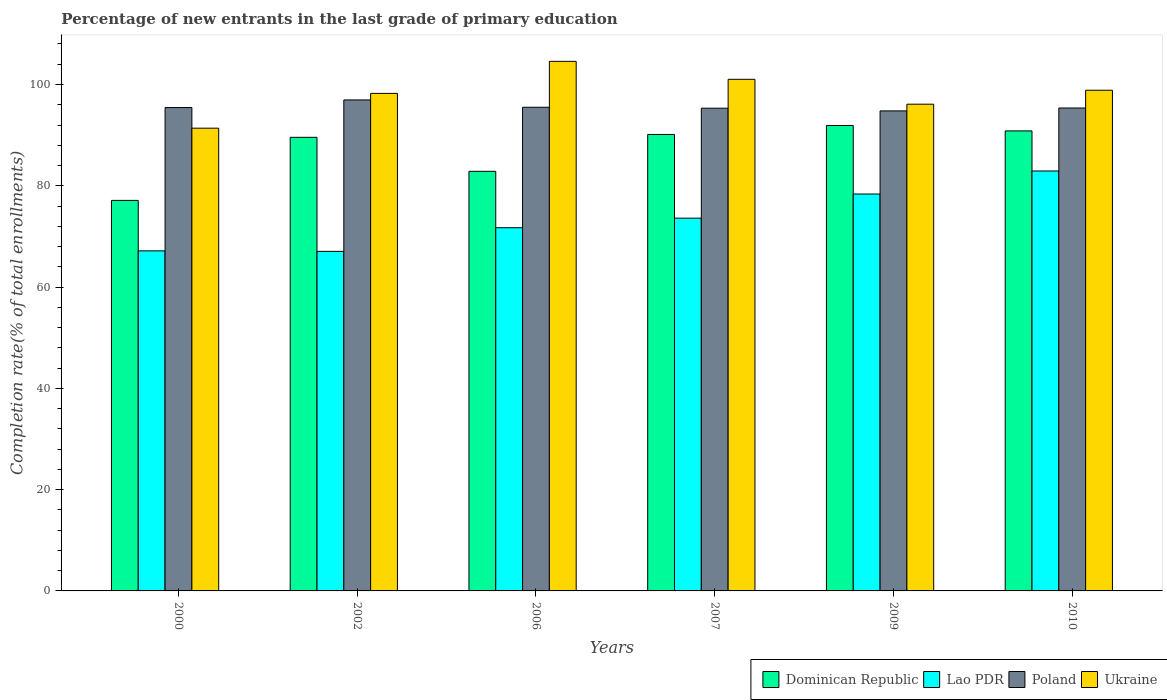How many different coloured bars are there?
Offer a very short reply. 4. What is the percentage of new entrants in Poland in 2006?
Your response must be concise. 95.51. Across all years, what is the maximum percentage of new entrants in Ukraine?
Provide a succinct answer. 104.57. Across all years, what is the minimum percentage of new entrants in Lao PDR?
Provide a succinct answer. 67.05. In which year was the percentage of new entrants in Ukraine maximum?
Your response must be concise. 2006. In which year was the percentage of new entrants in Poland minimum?
Provide a short and direct response. 2009. What is the total percentage of new entrants in Poland in the graph?
Provide a short and direct response. 573.39. What is the difference between the percentage of new entrants in Dominican Republic in 2000 and that in 2002?
Make the answer very short. -12.46. What is the difference between the percentage of new entrants in Lao PDR in 2000 and the percentage of new entrants in Dominican Republic in 2009?
Provide a succinct answer. -24.77. What is the average percentage of new entrants in Lao PDR per year?
Offer a terse response. 73.47. In the year 2010, what is the difference between the percentage of new entrants in Poland and percentage of new entrants in Lao PDR?
Your response must be concise. 12.44. What is the ratio of the percentage of new entrants in Poland in 2000 to that in 2010?
Offer a very short reply. 1. Is the percentage of new entrants in Ukraine in 2000 less than that in 2007?
Ensure brevity in your answer.  Yes. What is the difference between the highest and the second highest percentage of new entrants in Poland?
Your answer should be compact. 1.45. What is the difference between the highest and the lowest percentage of new entrants in Lao PDR?
Offer a terse response. 15.87. Is it the case that in every year, the sum of the percentage of new entrants in Ukraine and percentage of new entrants in Lao PDR is greater than the sum of percentage of new entrants in Poland and percentage of new entrants in Dominican Republic?
Give a very brief answer. Yes. What does the 4th bar from the left in 2000 represents?
Offer a very short reply. Ukraine. What does the 1st bar from the right in 2010 represents?
Offer a terse response. Ukraine. Are all the bars in the graph horizontal?
Keep it short and to the point. No. How many years are there in the graph?
Offer a very short reply. 6. What is the difference between two consecutive major ticks on the Y-axis?
Offer a terse response. 20. Are the values on the major ticks of Y-axis written in scientific E-notation?
Provide a succinct answer. No. Does the graph contain grids?
Make the answer very short. No. How are the legend labels stacked?
Keep it short and to the point. Horizontal. What is the title of the graph?
Ensure brevity in your answer.  Percentage of new entrants in the last grade of primary education. What is the label or title of the Y-axis?
Provide a succinct answer. Completion rate(% of total enrollments). What is the Completion rate(% of total enrollments) in Dominican Republic in 2000?
Ensure brevity in your answer.  77.12. What is the Completion rate(% of total enrollments) in Lao PDR in 2000?
Your response must be concise. 67.15. What is the Completion rate(% of total enrollments) in Poland in 2000?
Your response must be concise. 95.45. What is the Completion rate(% of total enrollments) in Ukraine in 2000?
Keep it short and to the point. 91.38. What is the Completion rate(% of total enrollments) in Dominican Republic in 2002?
Offer a very short reply. 89.57. What is the Completion rate(% of total enrollments) in Lao PDR in 2002?
Your answer should be compact. 67.05. What is the Completion rate(% of total enrollments) of Poland in 2002?
Offer a very short reply. 96.96. What is the Completion rate(% of total enrollments) in Ukraine in 2002?
Provide a succinct answer. 98.25. What is the Completion rate(% of total enrollments) in Dominican Republic in 2006?
Provide a short and direct response. 82.86. What is the Completion rate(% of total enrollments) in Lao PDR in 2006?
Your response must be concise. 71.72. What is the Completion rate(% of total enrollments) in Poland in 2006?
Offer a terse response. 95.51. What is the Completion rate(% of total enrollments) of Ukraine in 2006?
Give a very brief answer. 104.57. What is the Completion rate(% of total enrollments) in Dominican Republic in 2007?
Offer a terse response. 90.14. What is the Completion rate(% of total enrollments) in Lao PDR in 2007?
Give a very brief answer. 73.61. What is the Completion rate(% of total enrollments) of Poland in 2007?
Keep it short and to the point. 95.32. What is the Completion rate(% of total enrollments) of Ukraine in 2007?
Provide a succinct answer. 101.03. What is the Completion rate(% of total enrollments) in Dominican Republic in 2009?
Offer a very short reply. 91.91. What is the Completion rate(% of total enrollments) in Lao PDR in 2009?
Give a very brief answer. 78.37. What is the Completion rate(% of total enrollments) in Poland in 2009?
Offer a very short reply. 94.79. What is the Completion rate(% of total enrollments) of Ukraine in 2009?
Provide a succinct answer. 96.11. What is the Completion rate(% of total enrollments) in Dominican Republic in 2010?
Your response must be concise. 90.84. What is the Completion rate(% of total enrollments) in Lao PDR in 2010?
Give a very brief answer. 82.92. What is the Completion rate(% of total enrollments) in Poland in 2010?
Offer a terse response. 95.36. What is the Completion rate(% of total enrollments) in Ukraine in 2010?
Provide a succinct answer. 98.87. Across all years, what is the maximum Completion rate(% of total enrollments) of Dominican Republic?
Ensure brevity in your answer.  91.91. Across all years, what is the maximum Completion rate(% of total enrollments) of Lao PDR?
Give a very brief answer. 82.92. Across all years, what is the maximum Completion rate(% of total enrollments) of Poland?
Offer a very short reply. 96.96. Across all years, what is the maximum Completion rate(% of total enrollments) in Ukraine?
Your answer should be very brief. 104.57. Across all years, what is the minimum Completion rate(% of total enrollments) in Dominican Republic?
Ensure brevity in your answer.  77.12. Across all years, what is the minimum Completion rate(% of total enrollments) of Lao PDR?
Your answer should be compact. 67.05. Across all years, what is the minimum Completion rate(% of total enrollments) in Poland?
Provide a succinct answer. 94.79. Across all years, what is the minimum Completion rate(% of total enrollments) in Ukraine?
Your answer should be compact. 91.38. What is the total Completion rate(% of total enrollments) in Dominican Republic in the graph?
Offer a terse response. 522.43. What is the total Completion rate(% of total enrollments) of Lao PDR in the graph?
Offer a very short reply. 440.83. What is the total Completion rate(% of total enrollments) in Poland in the graph?
Give a very brief answer. 573.39. What is the total Completion rate(% of total enrollments) of Ukraine in the graph?
Your response must be concise. 590.21. What is the difference between the Completion rate(% of total enrollments) in Dominican Republic in 2000 and that in 2002?
Your response must be concise. -12.46. What is the difference between the Completion rate(% of total enrollments) in Lao PDR in 2000 and that in 2002?
Offer a very short reply. 0.1. What is the difference between the Completion rate(% of total enrollments) in Poland in 2000 and that in 2002?
Provide a short and direct response. -1.51. What is the difference between the Completion rate(% of total enrollments) in Ukraine in 2000 and that in 2002?
Keep it short and to the point. -6.87. What is the difference between the Completion rate(% of total enrollments) of Dominican Republic in 2000 and that in 2006?
Provide a succinct answer. -5.74. What is the difference between the Completion rate(% of total enrollments) in Lao PDR in 2000 and that in 2006?
Make the answer very short. -4.58. What is the difference between the Completion rate(% of total enrollments) in Poland in 2000 and that in 2006?
Offer a terse response. -0.06. What is the difference between the Completion rate(% of total enrollments) of Ukraine in 2000 and that in 2006?
Offer a terse response. -13.2. What is the difference between the Completion rate(% of total enrollments) in Dominican Republic in 2000 and that in 2007?
Your answer should be compact. -13.02. What is the difference between the Completion rate(% of total enrollments) of Lao PDR in 2000 and that in 2007?
Your answer should be very brief. -6.46. What is the difference between the Completion rate(% of total enrollments) in Poland in 2000 and that in 2007?
Your answer should be very brief. 0.13. What is the difference between the Completion rate(% of total enrollments) in Ukraine in 2000 and that in 2007?
Your answer should be compact. -9.65. What is the difference between the Completion rate(% of total enrollments) of Dominican Republic in 2000 and that in 2009?
Your answer should be very brief. -14.8. What is the difference between the Completion rate(% of total enrollments) in Lao PDR in 2000 and that in 2009?
Your answer should be very brief. -11.23. What is the difference between the Completion rate(% of total enrollments) in Poland in 2000 and that in 2009?
Give a very brief answer. 0.66. What is the difference between the Completion rate(% of total enrollments) in Ukraine in 2000 and that in 2009?
Make the answer very short. -4.74. What is the difference between the Completion rate(% of total enrollments) in Dominican Republic in 2000 and that in 2010?
Keep it short and to the point. -13.72. What is the difference between the Completion rate(% of total enrollments) in Lao PDR in 2000 and that in 2010?
Your response must be concise. -15.78. What is the difference between the Completion rate(% of total enrollments) in Poland in 2000 and that in 2010?
Ensure brevity in your answer.  0.09. What is the difference between the Completion rate(% of total enrollments) in Ukraine in 2000 and that in 2010?
Your answer should be compact. -7.49. What is the difference between the Completion rate(% of total enrollments) in Dominican Republic in 2002 and that in 2006?
Provide a succinct answer. 6.72. What is the difference between the Completion rate(% of total enrollments) of Lao PDR in 2002 and that in 2006?
Provide a succinct answer. -4.67. What is the difference between the Completion rate(% of total enrollments) in Poland in 2002 and that in 2006?
Provide a short and direct response. 1.45. What is the difference between the Completion rate(% of total enrollments) of Ukraine in 2002 and that in 2006?
Provide a succinct answer. -6.32. What is the difference between the Completion rate(% of total enrollments) in Dominican Republic in 2002 and that in 2007?
Make the answer very short. -0.56. What is the difference between the Completion rate(% of total enrollments) in Lao PDR in 2002 and that in 2007?
Your response must be concise. -6.56. What is the difference between the Completion rate(% of total enrollments) of Poland in 2002 and that in 2007?
Your answer should be compact. 1.63. What is the difference between the Completion rate(% of total enrollments) in Ukraine in 2002 and that in 2007?
Offer a terse response. -2.78. What is the difference between the Completion rate(% of total enrollments) of Dominican Republic in 2002 and that in 2009?
Your answer should be very brief. -2.34. What is the difference between the Completion rate(% of total enrollments) of Lao PDR in 2002 and that in 2009?
Ensure brevity in your answer.  -11.32. What is the difference between the Completion rate(% of total enrollments) of Poland in 2002 and that in 2009?
Ensure brevity in your answer.  2.17. What is the difference between the Completion rate(% of total enrollments) of Ukraine in 2002 and that in 2009?
Provide a short and direct response. 2.13. What is the difference between the Completion rate(% of total enrollments) of Dominican Republic in 2002 and that in 2010?
Ensure brevity in your answer.  -1.26. What is the difference between the Completion rate(% of total enrollments) of Lao PDR in 2002 and that in 2010?
Ensure brevity in your answer.  -15.87. What is the difference between the Completion rate(% of total enrollments) in Poland in 2002 and that in 2010?
Keep it short and to the point. 1.59. What is the difference between the Completion rate(% of total enrollments) of Ukraine in 2002 and that in 2010?
Offer a very short reply. -0.62. What is the difference between the Completion rate(% of total enrollments) in Dominican Republic in 2006 and that in 2007?
Keep it short and to the point. -7.28. What is the difference between the Completion rate(% of total enrollments) of Lao PDR in 2006 and that in 2007?
Ensure brevity in your answer.  -1.89. What is the difference between the Completion rate(% of total enrollments) of Poland in 2006 and that in 2007?
Provide a short and direct response. 0.19. What is the difference between the Completion rate(% of total enrollments) in Ukraine in 2006 and that in 2007?
Offer a very short reply. 3.55. What is the difference between the Completion rate(% of total enrollments) in Dominican Republic in 2006 and that in 2009?
Offer a very short reply. -9.06. What is the difference between the Completion rate(% of total enrollments) in Lao PDR in 2006 and that in 2009?
Your answer should be very brief. -6.65. What is the difference between the Completion rate(% of total enrollments) of Poland in 2006 and that in 2009?
Your answer should be very brief. 0.72. What is the difference between the Completion rate(% of total enrollments) of Ukraine in 2006 and that in 2009?
Keep it short and to the point. 8.46. What is the difference between the Completion rate(% of total enrollments) of Dominican Republic in 2006 and that in 2010?
Give a very brief answer. -7.98. What is the difference between the Completion rate(% of total enrollments) in Lao PDR in 2006 and that in 2010?
Your answer should be compact. -11.2. What is the difference between the Completion rate(% of total enrollments) of Poland in 2006 and that in 2010?
Ensure brevity in your answer.  0.14. What is the difference between the Completion rate(% of total enrollments) in Ukraine in 2006 and that in 2010?
Make the answer very short. 5.7. What is the difference between the Completion rate(% of total enrollments) of Dominican Republic in 2007 and that in 2009?
Your answer should be very brief. -1.78. What is the difference between the Completion rate(% of total enrollments) of Lao PDR in 2007 and that in 2009?
Your answer should be compact. -4.77. What is the difference between the Completion rate(% of total enrollments) in Poland in 2007 and that in 2009?
Give a very brief answer. 0.53. What is the difference between the Completion rate(% of total enrollments) of Ukraine in 2007 and that in 2009?
Your response must be concise. 4.91. What is the difference between the Completion rate(% of total enrollments) of Dominican Republic in 2007 and that in 2010?
Keep it short and to the point. -0.7. What is the difference between the Completion rate(% of total enrollments) of Lao PDR in 2007 and that in 2010?
Keep it short and to the point. -9.31. What is the difference between the Completion rate(% of total enrollments) in Poland in 2007 and that in 2010?
Your answer should be compact. -0.04. What is the difference between the Completion rate(% of total enrollments) of Ukraine in 2007 and that in 2010?
Provide a succinct answer. 2.16. What is the difference between the Completion rate(% of total enrollments) in Dominican Republic in 2009 and that in 2010?
Offer a terse response. 1.08. What is the difference between the Completion rate(% of total enrollments) in Lao PDR in 2009 and that in 2010?
Your response must be concise. -4.55. What is the difference between the Completion rate(% of total enrollments) in Poland in 2009 and that in 2010?
Offer a terse response. -0.57. What is the difference between the Completion rate(% of total enrollments) in Ukraine in 2009 and that in 2010?
Your answer should be very brief. -2.76. What is the difference between the Completion rate(% of total enrollments) of Dominican Republic in 2000 and the Completion rate(% of total enrollments) of Lao PDR in 2002?
Ensure brevity in your answer.  10.06. What is the difference between the Completion rate(% of total enrollments) in Dominican Republic in 2000 and the Completion rate(% of total enrollments) in Poland in 2002?
Provide a succinct answer. -19.84. What is the difference between the Completion rate(% of total enrollments) of Dominican Republic in 2000 and the Completion rate(% of total enrollments) of Ukraine in 2002?
Keep it short and to the point. -21.13. What is the difference between the Completion rate(% of total enrollments) of Lao PDR in 2000 and the Completion rate(% of total enrollments) of Poland in 2002?
Make the answer very short. -29.81. What is the difference between the Completion rate(% of total enrollments) in Lao PDR in 2000 and the Completion rate(% of total enrollments) in Ukraine in 2002?
Provide a short and direct response. -31.1. What is the difference between the Completion rate(% of total enrollments) in Poland in 2000 and the Completion rate(% of total enrollments) in Ukraine in 2002?
Provide a succinct answer. -2.8. What is the difference between the Completion rate(% of total enrollments) of Dominican Republic in 2000 and the Completion rate(% of total enrollments) of Lao PDR in 2006?
Provide a succinct answer. 5.39. What is the difference between the Completion rate(% of total enrollments) in Dominican Republic in 2000 and the Completion rate(% of total enrollments) in Poland in 2006?
Give a very brief answer. -18.39. What is the difference between the Completion rate(% of total enrollments) of Dominican Republic in 2000 and the Completion rate(% of total enrollments) of Ukraine in 2006?
Give a very brief answer. -27.46. What is the difference between the Completion rate(% of total enrollments) in Lao PDR in 2000 and the Completion rate(% of total enrollments) in Poland in 2006?
Provide a succinct answer. -28.36. What is the difference between the Completion rate(% of total enrollments) in Lao PDR in 2000 and the Completion rate(% of total enrollments) in Ukraine in 2006?
Make the answer very short. -37.42. What is the difference between the Completion rate(% of total enrollments) of Poland in 2000 and the Completion rate(% of total enrollments) of Ukraine in 2006?
Ensure brevity in your answer.  -9.12. What is the difference between the Completion rate(% of total enrollments) in Dominican Republic in 2000 and the Completion rate(% of total enrollments) in Lao PDR in 2007?
Keep it short and to the point. 3.51. What is the difference between the Completion rate(% of total enrollments) of Dominican Republic in 2000 and the Completion rate(% of total enrollments) of Poland in 2007?
Offer a very short reply. -18.21. What is the difference between the Completion rate(% of total enrollments) of Dominican Republic in 2000 and the Completion rate(% of total enrollments) of Ukraine in 2007?
Give a very brief answer. -23.91. What is the difference between the Completion rate(% of total enrollments) in Lao PDR in 2000 and the Completion rate(% of total enrollments) in Poland in 2007?
Give a very brief answer. -28.17. What is the difference between the Completion rate(% of total enrollments) in Lao PDR in 2000 and the Completion rate(% of total enrollments) in Ukraine in 2007?
Offer a terse response. -33.88. What is the difference between the Completion rate(% of total enrollments) of Poland in 2000 and the Completion rate(% of total enrollments) of Ukraine in 2007?
Your answer should be very brief. -5.58. What is the difference between the Completion rate(% of total enrollments) of Dominican Republic in 2000 and the Completion rate(% of total enrollments) of Lao PDR in 2009?
Your answer should be very brief. -1.26. What is the difference between the Completion rate(% of total enrollments) of Dominican Republic in 2000 and the Completion rate(% of total enrollments) of Poland in 2009?
Ensure brevity in your answer.  -17.68. What is the difference between the Completion rate(% of total enrollments) in Dominican Republic in 2000 and the Completion rate(% of total enrollments) in Ukraine in 2009?
Offer a very short reply. -19. What is the difference between the Completion rate(% of total enrollments) of Lao PDR in 2000 and the Completion rate(% of total enrollments) of Poland in 2009?
Your response must be concise. -27.64. What is the difference between the Completion rate(% of total enrollments) in Lao PDR in 2000 and the Completion rate(% of total enrollments) in Ukraine in 2009?
Provide a short and direct response. -28.97. What is the difference between the Completion rate(% of total enrollments) in Poland in 2000 and the Completion rate(% of total enrollments) in Ukraine in 2009?
Offer a terse response. -0.66. What is the difference between the Completion rate(% of total enrollments) in Dominican Republic in 2000 and the Completion rate(% of total enrollments) in Lao PDR in 2010?
Provide a succinct answer. -5.81. What is the difference between the Completion rate(% of total enrollments) of Dominican Republic in 2000 and the Completion rate(% of total enrollments) of Poland in 2010?
Ensure brevity in your answer.  -18.25. What is the difference between the Completion rate(% of total enrollments) in Dominican Republic in 2000 and the Completion rate(% of total enrollments) in Ukraine in 2010?
Give a very brief answer. -21.76. What is the difference between the Completion rate(% of total enrollments) in Lao PDR in 2000 and the Completion rate(% of total enrollments) in Poland in 2010?
Your answer should be compact. -28.22. What is the difference between the Completion rate(% of total enrollments) in Lao PDR in 2000 and the Completion rate(% of total enrollments) in Ukraine in 2010?
Make the answer very short. -31.72. What is the difference between the Completion rate(% of total enrollments) of Poland in 2000 and the Completion rate(% of total enrollments) of Ukraine in 2010?
Offer a terse response. -3.42. What is the difference between the Completion rate(% of total enrollments) in Dominican Republic in 2002 and the Completion rate(% of total enrollments) in Lao PDR in 2006?
Keep it short and to the point. 17.85. What is the difference between the Completion rate(% of total enrollments) of Dominican Republic in 2002 and the Completion rate(% of total enrollments) of Poland in 2006?
Your response must be concise. -5.93. What is the difference between the Completion rate(% of total enrollments) of Lao PDR in 2002 and the Completion rate(% of total enrollments) of Poland in 2006?
Your answer should be very brief. -28.46. What is the difference between the Completion rate(% of total enrollments) of Lao PDR in 2002 and the Completion rate(% of total enrollments) of Ukraine in 2006?
Offer a very short reply. -37.52. What is the difference between the Completion rate(% of total enrollments) in Poland in 2002 and the Completion rate(% of total enrollments) in Ukraine in 2006?
Your response must be concise. -7.62. What is the difference between the Completion rate(% of total enrollments) of Dominican Republic in 2002 and the Completion rate(% of total enrollments) of Lao PDR in 2007?
Your answer should be compact. 15.96. What is the difference between the Completion rate(% of total enrollments) of Dominican Republic in 2002 and the Completion rate(% of total enrollments) of Poland in 2007?
Make the answer very short. -5.75. What is the difference between the Completion rate(% of total enrollments) in Dominican Republic in 2002 and the Completion rate(% of total enrollments) in Ukraine in 2007?
Give a very brief answer. -11.45. What is the difference between the Completion rate(% of total enrollments) of Lao PDR in 2002 and the Completion rate(% of total enrollments) of Poland in 2007?
Keep it short and to the point. -28.27. What is the difference between the Completion rate(% of total enrollments) of Lao PDR in 2002 and the Completion rate(% of total enrollments) of Ukraine in 2007?
Provide a succinct answer. -33.98. What is the difference between the Completion rate(% of total enrollments) of Poland in 2002 and the Completion rate(% of total enrollments) of Ukraine in 2007?
Your response must be concise. -4.07. What is the difference between the Completion rate(% of total enrollments) of Dominican Republic in 2002 and the Completion rate(% of total enrollments) of Lao PDR in 2009?
Your answer should be compact. 11.2. What is the difference between the Completion rate(% of total enrollments) in Dominican Republic in 2002 and the Completion rate(% of total enrollments) in Poland in 2009?
Offer a very short reply. -5.22. What is the difference between the Completion rate(% of total enrollments) in Dominican Republic in 2002 and the Completion rate(% of total enrollments) in Ukraine in 2009?
Keep it short and to the point. -6.54. What is the difference between the Completion rate(% of total enrollments) in Lao PDR in 2002 and the Completion rate(% of total enrollments) in Poland in 2009?
Provide a short and direct response. -27.74. What is the difference between the Completion rate(% of total enrollments) in Lao PDR in 2002 and the Completion rate(% of total enrollments) in Ukraine in 2009?
Your response must be concise. -29.06. What is the difference between the Completion rate(% of total enrollments) of Poland in 2002 and the Completion rate(% of total enrollments) of Ukraine in 2009?
Your answer should be compact. 0.84. What is the difference between the Completion rate(% of total enrollments) of Dominican Republic in 2002 and the Completion rate(% of total enrollments) of Lao PDR in 2010?
Give a very brief answer. 6.65. What is the difference between the Completion rate(% of total enrollments) in Dominican Republic in 2002 and the Completion rate(% of total enrollments) in Poland in 2010?
Your response must be concise. -5.79. What is the difference between the Completion rate(% of total enrollments) in Dominican Republic in 2002 and the Completion rate(% of total enrollments) in Ukraine in 2010?
Offer a very short reply. -9.3. What is the difference between the Completion rate(% of total enrollments) of Lao PDR in 2002 and the Completion rate(% of total enrollments) of Poland in 2010?
Ensure brevity in your answer.  -28.31. What is the difference between the Completion rate(% of total enrollments) in Lao PDR in 2002 and the Completion rate(% of total enrollments) in Ukraine in 2010?
Your answer should be very brief. -31.82. What is the difference between the Completion rate(% of total enrollments) of Poland in 2002 and the Completion rate(% of total enrollments) of Ukraine in 2010?
Your response must be concise. -1.91. What is the difference between the Completion rate(% of total enrollments) of Dominican Republic in 2006 and the Completion rate(% of total enrollments) of Lao PDR in 2007?
Make the answer very short. 9.25. What is the difference between the Completion rate(% of total enrollments) in Dominican Republic in 2006 and the Completion rate(% of total enrollments) in Poland in 2007?
Offer a terse response. -12.47. What is the difference between the Completion rate(% of total enrollments) of Dominican Republic in 2006 and the Completion rate(% of total enrollments) of Ukraine in 2007?
Make the answer very short. -18.17. What is the difference between the Completion rate(% of total enrollments) of Lao PDR in 2006 and the Completion rate(% of total enrollments) of Poland in 2007?
Give a very brief answer. -23.6. What is the difference between the Completion rate(% of total enrollments) in Lao PDR in 2006 and the Completion rate(% of total enrollments) in Ukraine in 2007?
Your answer should be very brief. -29.3. What is the difference between the Completion rate(% of total enrollments) of Poland in 2006 and the Completion rate(% of total enrollments) of Ukraine in 2007?
Keep it short and to the point. -5.52. What is the difference between the Completion rate(% of total enrollments) of Dominican Republic in 2006 and the Completion rate(% of total enrollments) of Lao PDR in 2009?
Provide a short and direct response. 4.48. What is the difference between the Completion rate(% of total enrollments) in Dominican Republic in 2006 and the Completion rate(% of total enrollments) in Poland in 2009?
Offer a very short reply. -11.93. What is the difference between the Completion rate(% of total enrollments) of Dominican Republic in 2006 and the Completion rate(% of total enrollments) of Ukraine in 2009?
Give a very brief answer. -13.26. What is the difference between the Completion rate(% of total enrollments) of Lao PDR in 2006 and the Completion rate(% of total enrollments) of Poland in 2009?
Provide a succinct answer. -23.07. What is the difference between the Completion rate(% of total enrollments) in Lao PDR in 2006 and the Completion rate(% of total enrollments) in Ukraine in 2009?
Offer a terse response. -24.39. What is the difference between the Completion rate(% of total enrollments) of Poland in 2006 and the Completion rate(% of total enrollments) of Ukraine in 2009?
Give a very brief answer. -0.61. What is the difference between the Completion rate(% of total enrollments) of Dominican Republic in 2006 and the Completion rate(% of total enrollments) of Lao PDR in 2010?
Ensure brevity in your answer.  -0.07. What is the difference between the Completion rate(% of total enrollments) in Dominican Republic in 2006 and the Completion rate(% of total enrollments) in Poland in 2010?
Provide a short and direct response. -12.51. What is the difference between the Completion rate(% of total enrollments) in Dominican Republic in 2006 and the Completion rate(% of total enrollments) in Ukraine in 2010?
Offer a terse response. -16.01. What is the difference between the Completion rate(% of total enrollments) in Lao PDR in 2006 and the Completion rate(% of total enrollments) in Poland in 2010?
Keep it short and to the point. -23.64. What is the difference between the Completion rate(% of total enrollments) of Lao PDR in 2006 and the Completion rate(% of total enrollments) of Ukraine in 2010?
Ensure brevity in your answer.  -27.15. What is the difference between the Completion rate(% of total enrollments) of Poland in 2006 and the Completion rate(% of total enrollments) of Ukraine in 2010?
Make the answer very short. -3.36. What is the difference between the Completion rate(% of total enrollments) of Dominican Republic in 2007 and the Completion rate(% of total enrollments) of Lao PDR in 2009?
Give a very brief answer. 11.76. What is the difference between the Completion rate(% of total enrollments) in Dominican Republic in 2007 and the Completion rate(% of total enrollments) in Poland in 2009?
Provide a short and direct response. -4.65. What is the difference between the Completion rate(% of total enrollments) in Dominican Republic in 2007 and the Completion rate(% of total enrollments) in Ukraine in 2009?
Provide a succinct answer. -5.98. What is the difference between the Completion rate(% of total enrollments) of Lao PDR in 2007 and the Completion rate(% of total enrollments) of Poland in 2009?
Provide a succinct answer. -21.18. What is the difference between the Completion rate(% of total enrollments) in Lao PDR in 2007 and the Completion rate(% of total enrollments) in Ukraine in 2009?
Give a very brief answer. -22.5. What is the difference between the Completion rate(% of total enrollments) in Poland in 2007 and the Completion rate(% of total enrollments) in Ukraine in 2009?
Your answer should be compact. -0.79. What is the difference between the Completion rate(% of total enrollments) in Dominican Republic in 2007 and the Completion rate(% of total enrollments) in Lao PDR in 2010?
Your answer should be compact. 7.21. What is the difference between the Completion rate(% of total enrollments) of Dominican Republic in 2007 and the Completion rate(% of total enrollments) of Poland in 2010?
Offer a very short reply. -5.23. What is the difference between the Completion rate(% of total enrollments) of Dominican Republic in 2007 and the Completion rate(% of total enrollments) of Ukraine in 2010?
Provide a succinct answer. -8.73. What is the difference between the Completion rate(% of total enrollments) in Lao PDR in 2007 and the Completion rate(% of total enrollments) in Poland in 2010?
Ensure brevity in your answer.  -21.75. What is the difference between the Completion rate(% of total enrollments) of Lao PDR in 2007 and the Completion rate(% of total enrollments) of Ukraine in 2010?
Make the answer very short. -25.26. What is the difference between the Completion rate(% of total enrollments) of Poland in 2007 and the Completion rate(% of total enrollments) of Ukraine in 2010?
Keep it short and to the point. -3.55. What is the difference between the Completion rate(% of total enrollments) in Dominican Republic in 2009 and the Completion rate(% of total enrollments) in Lao PDR in 2010?
Provide a short and direct response. 8.99. What is the difference between the Completion rate(% of total enrollments) in Dominican Republic in 2009 and the Completion rate(% of total enrollments) in Poland in 2010?
Provide a succinct answer. -3.45. What is the difference between the Completion rate(% of total enrollments) in Dominican Republic in 2009 and the Completion rate(% of total enrollments) in Ukraine in 2010?
Offer a very short reply. -6.96. What is the difference between the Completion rate(% of total enrollments) of Lao PDR in 2009 and the Completion rate(% of total enrollments) of Poland in 2010?
Your response must be concise. -16.99. What is the difference between the Completion rate(% of total enrollments) in Lao PDR in 2009 and the Completion rate(% of total enrollments) in Ukraine in 2010?
Your answer should be compact. -20.5. What is the difference between the Completion rate(% of total enrollments) in Poland in 2009 and the Completion rate(% of total enrollments) in Ukraine in 2010?
Keep it short and to the point. -4.08. What is the average Completion rate(% of total enrollments) in Dominican Republic per year?
Offer a terse response. 87.07. What is the average Completion rate(% of total enrollments) of Lao PDR per year?
Your answer should be compact. 73.47. What is the average Completion rate(% of total enrollments) in Poland per year?
Keep it short and to the point. 95.57. What is the average Completion rate(% of total enrollments) in Ukraine per year?
Make the answer very short. 98.37. In the year 2000, what is the difference between the Completion rate(% of total enrollments) in Dominican Republic and Completion rate(% of total enrollments) in Lao PDR?
Offer a very short reply. 9.97. In the year 2000, what is the difference between the Completion rate(% of total enrollments) in Dominican Republic and Completion rate(% of total enrollments) in Poland?
Provide a succinct answer. -18.34. In the year 2000, what is the difference between the Completion rate(% of total enrollments) of Dominican Republic and Completion rate(% of total enrollments) of Ukraine?
Make the answer very short. -14.26. In the year 2000, what is the difference between the Completion rate(% of total enrollments) of Lao PDR and Completion rate(% of total enrollments) of Poland?
Your answer should be compact. -28.3. In the year 2000, what is the difference between the Completion rate(% of total enrollments) of Lao PDR and Completion rate(% of total enrollments) of Ukraine?
Ensure brevity in your answer.  -24.23. In the year 2000, what is the difference between the Completion rate(% of total enrollments) in Poland and Completion rate(% of total enrollments) in Ukraine?
Offer a terse response. 4.07. In the year 2002, what is the difference between the Completion rate(% of total enrollments) in Dominican Republic and Completion rate(% of total enrollments) in Lao PDR?
Your answer should be very brief. 22.52. In the year 2002, what is the difference between the Completion rate(% of total enrollments) of Dominican Republic and Completion rate(% of total enrollments) of Poland?
Give a very brief answer. -7.38. In the year 2002, what is the difference between the Completion rate(% of total enrollments) of Dominican Republic and Completion rate(% of total enrollments) of Ukraine?
Provide a short and direct response. -8.68. In the year 2002, what is the difference between the Completion rate(% of total enrollments) of Lao PDR and Completion rate(% of total enrollments) of Poland?
Keep it short and to the point. -29.91. In the year 2002, what is the difference between the Completion rate(% of total enrollments) of Lao PDR and Completion rate(% of total enrollments) of Ukraine?
Provide a succinct answer. -31.2. In the year 2002, what is the difference between the Completion rate(% of total enrollments) in Poland and Completion rate(% of total enrollments) in Ukraine?
Make the answer very short. -1.29. In the year 2006, what is the difference between the Completion rate(% of total enrollments) in Dominican Republic and Completion rate(% of total enrollments) in Lao PDR?
Ensure brevity in your answer.  11.13. In the year 2006, what is the difference between the Completion rate(% of total enrollments) of Dominican Republic and Completion rate(% of total enrollments) of Poland?
Ensure brevity in your answer.  -12.65. In the year 2006, what is the difference between the Completion rate(% of total enrollments) of Dominican Republic and Completion rate(% of total enrollments) of Ukraine?
Keep it short and to the point. -21.72. In the year 2006, what is the difference between the Completion rate(% of total enrollments) of Lao PDR and Completion rate(% of total enrollments) of Poland?
Make the answer very short. -23.78. In the year 2006, what is the difference between the Completion rate(% of total enrollments) of Lao PDR and Completion rate(% of total enrollments) of Ukraine?
Offer a terse response. -32.85. In the year 2006, what is the difference between the Completion rate(% of total enrollments) in Poland and Completion rate(% of total enrollments) in Ukraine?
Offer a terse response. -9.07. In the year 2007, what is the difference between the Completion rate(% of total enrollments) of Dominican Republic and Completion rate(% of total enrollments) of Lao PDR?
Keep it short and to the point. 16.53. In the year 2007, what is the difference between the Completion rate(% of total enrollments) of Dominican Republic and Completion rate(% of total enrollments) of Poland?
Your answer should be very brief. -5.19. In the year 2007, what is the difference between the Completion rate(% of total enrollments) in Dominican Republic and Completion rate(% of total enrollments) in Ukraine?
Ensure brevity in your answer.  -10.89. In the year 2007, what is the difference between the Completion rate(% of total enrollments) of Lao PDR and Completion rate(% of total enrollments) of Poland?
Make the answer very short. -21.71. In the year 2007, what is the difference between the Completion rate(% of total enrollments) of Lao PDR and Completion rate(% of total enrollments) of Ukraine?
Make the answer very short. -27.42. In the year 2007, what is the difference between the Completion rate(% of total enrollments) of Poland and Completion rate(% of total enrollments) of Ukraine?
Ensure brevity in your answer.  -5.7. In the year 2009, what is the difference between the Completion rate(% of total enrollments) of Dominican Republic and Completion rate(% of total enrollments) of Lao PDR?
Offer a terse response. 13.54. In the year 2009, what is the difference between the Completion rate(% of total enrollments) in Dominican Republic and Completion rate(% of total enrollments) in Poland?
Your response must be concise. -2.88. In the year 2009, what is the difference between the Completion rate(% of total enrollments) of Dominican Republic and Completion rate(% of total enrollments) of Ukraine?
Offer a terse response. -4.2. In the year 2009, what is the difference between the Completion rate(% of total enrollments) of Lao PDR and Completion rate(% of total enrollments) of Poland?
Keep it short and to the point. -16.42. In the year 2009, what is the difference between the Completion rate(% of total enrollments) in Lao PDR and Completion rate(% of total enrollments) in Ukraine?
Ensure brevity in your answer.  -17.74. In the year 2009, what is the difference between the Completion rate(% of total enrollments) of Poland and Completion rate(% of total enrollments) of Ukraine?
Ensure brevity in your answer.  -1.32. In the year 2010, what is the difference between the Completion rate(% of total enrollments) of Dominican Republic and Completion rate(% of total enrollments) of Lao PDR?
Keep it short and to the point. 7.91. In the year 2010, what is the difference between the Completion rate(% of total enrollments) of Dominican Republic and Completion rate(% of total enrollments) of Poland?
Your response must be concise. -4.53. In the year 2010, what is the difference between the Completion rate(% of total enrollments) of Dominican Republic and Completion rate(% of total enrollments) of Ukraine?
Provide a succinct answer. -8.03. In the year 2010, what is the difference between the Completion rate(% of total enrollments) in Lao PDR and Completion rate(% of total enrollments) in Poland?
Provide a short and direct response. -12.44. In the year 2010, what is the difference between the Completion rate(% of total enrollments) of Lao PDR and Completion rate(% of total enrollments) of Ukraine?
Offer a very short reply. -15.95. In the year 2010, what is the difference between the Completion rate(% of total enrollments) in Poland and Completion rate(% of total enrollments) in Ukraine?
Your answer should be compact. -3.51. What is the ratio of the Completion rate(% of total enrollments) in Dominican Republic in 2000 to that in 2002?
Keep it short and to the point. 0.86. What is the ratio of the Completion rate(% of total enrollments) in Lao PDR in 2000 to that in 2002?
Your response must be concise. 1. What is the ratio of the Completion rate(% of total enrollments) in Poland in 2000 to that in 2002?
Your answer should be compact. 0.98. What is the ratio of the Completion rate(% of total enrollments) of Ukraine in 2000 to that in 2002?
Your response must be concise. 0.93. What is the ratio of the Completion rate(% of total enrollments) in Dominican Republic in 2000 to that in 2006?
Keep it short and to the point. 0.93. What is the ratio of the Completion rate(% of total enrollments) in Lao PDR in 2000 to that in 2006?
Make the answer very short. 0.94. What is the ratio of the Completion rate(% of total enrollments) in Ukraine in 2000 to that in 2006?
Your response must be concise. 0.87. What is the ratio of the Completion rate(% of total enrollments) of Dominican Republic in 2000 to that in 2007?
Make the answer very short. 0.86. What is the ratio of the Completion rate(% of total enrollments) of Lao PDR in 2000 to that in 2007?
Ensure brevity in your answer.  0.91. What is the ratio of the Completion rate(% of total enrollments) in Ukraine in 2000 to that in 2007?
Provide a succinct answer. 0.9. What is the ratio of the Completion rate(% of total enrollments) of Dominican Republic in 2000 to that in 2009?
Make the answer very short. 0.84. What is the ratio of the Completion rate(% of total enrollments) in Lao PDR in 2000 to that in 2009?
Offer a terse response. 0.86. What is the ratio of the Completion rate(% of total enrollments) in Poland in 2000 to that in 2009?
Ensure brevity in your answer.  1.01. What is the ratio of the Completion rate(% of total enrollments) in Ukraine in 2000 to that in 2009?
Provide a short and direct response. 0.95. What is the ratio of the Completion rate(% of total enrollments) in Dominican Republic in 2000 to that in 2010?
Provide a succinct answer. 0.85. What is the ratio of the Completion rate(% of total enrollments) in Lao PDR in 2000 to that in 2010?
Provide a short and direct response. 0.81. What is the ratio of the Completion rate(% of total enrollments) of Ukraine in 2000 to that in 2010?
Ensure brevity in your answer.  0.92. What is the ratio of the Completion rate(% of total enrollments) in Dominican Republic in 2002 to that in 2006?
Make the answer very short. 1.08. What is the ratio of the Completion rate(% of total enrollments) of Lao PDR in 2002 to that in 2006?
Keep it short and to the point. 0.93. What is the ratio of the Completion rate(% of total enrollments) of Poland in 2002 to that in 2006?
Provide a short and direct response. 1.02. What is the ratio of the Completion rate(% of total enrollments) of Ukraine in 2002 to that in 2006?
Offer a very short reply. 0.94. What is the ratio of the Completion rate(% of total enrollments) in Lao PDR in 2002 to that in 2007?
Provide a succinct answer. 0.91. What is the ratio of the Completion rate(% of total enrollments) of Poland in 2002 to that in 2007?
Offer a terse response. 1.02. What is the ratio of the Completion rate(% of total enrollments) of Ukraine in 2002 to that in 2007?
Ensure brevity in your answer.  0.97. What is the ratio of the Completion rate(% of total enrollments) of Dominican Republic in 2002 to that in 2009?
Offer a very short reply. 0.97. What is the ratio of the Completion rate(% of total enrollments) in Lao PDR in 2002 to that in 2009?
Give a very brief answer. 0.86. What is the ratio of the Completion rate(% of total enrollments) in Poland in 2002 to that in 2009?
Your answer should be compact. 1.02. What is the ratio of the Completion rate(% of total enrollments) of Ukraine in 2002 to that in 2009?
Offer a very short reply. 1.02. What is the ratio of the Completion rate(% of total enrollments) of Dominican Republic in 2002 to that in 2010?
Ensure brevity in your answer.  0.99. What is the ratio of the Completion rate(% of total enrollments) of Lao PDR in 2002 to that in 2010?
Provide a succinct answer. 0.81. What is the ratio of the Completion rate(% of total enrollments) in Poland in 2002 to that in 2010?
Give a very brief answer. 1.02. What is the ratio of the Completion rate(% of total enrollments) of Dominican Republic in 2006 to that in 2007?
Offer a terse response. 0.92. What is the ratio of the Completion rate(% of total enrollments) of Lao PDR in 2006 to that in 2007?
Make the answer very short. 0.97. What is the ratio of the Completion rate(% of total enrollments) of Poland in 2006 to that in 2007?
Ensure brevity in your answer.  1. What is the ratio of the Completion rate(% of total enrollments) of Ukraine in 2006 to that in 2007?
Provide a short and direct response. 1.04. What is the ratio of the Completion rate(% of total enrollments) of Dominican Republic in 2006 to that in 2009?
Your answer should be compact. 0.9. What is the ratio of the Completion rate(% of total enrollments) in Lao PDR in 2006 to that in 2009?
Your answer should be compact. 0.92. What is the ratio of the Completion rate(% of total enrollments) of Poland in 2006 to that in 2009?
Offer a terse response. 1.01. What is the ratio of the Completion rate(% of total enrollments) of Ukraine in 2006 to that in 2009?
Provide a succinct answer. 1.09. What is the ratio of the Completion rate(% of total enrollments) in Dominican Republic in 2006 to that in 2010?
Offer a very short reply. 0.91. What is the ratio of the Completion rate(% of total enrollments) in Lao PDR in 2006 to that in 2010?
Your answer should be compact. 0.86. What is the ratio of the Completion rate(% of total enrollments) in Poland in 2006 to that in 2010?
Make the answer very short. 1. What is the ratio of the Completion rate(% of total enrollments) of Ukraine in 2006 to that in 2010?
Make the answer very short. 1.06. What is the ratio of the Completion rate(% of total enrollments) in Dominican Republic in 2007 to that in 2009?
Your answer should be very brief. 0.98. What is the ratio of the Completion rate(% of total enrollments) in Lao PDR in 2007 to that in 2009?
Your answer should be compact. 0.94. What is the ratio of the Completion rate(% of total enrollments) in Poland in 2007 to that in 2009?
Provide a short and direct response. 1.01. What is the ratio of the Completion rate(% of total enrollments) in Ukraine in 2007 to that in 2009?
Make the answer very short. 1.05. What is the ratio of the Completion rate(% of total enrollments) of Dominican Republic in 2007 to that in 2010?
Give a very brief answer. 0.99. What is the ratio of the Completion rate(% of total enrollments) of Lao PDR in 2007 to that in 2010?
Ensure brevity in your answer.  0.89. What is the ratio of the Completion rate(% of total enrollments) in Poland in 2007 to that in 2010?
Provide a succinct answer. 1. What is the ratio of the Completion rate(% of total enrollments) in Ukraine in 2007 to that in 2010?
Offer a very short reply. 1.02. What is the ratio of the Completion rate(% of total enrollments) of Dominican Republic in 2009 to that in 2010?
Offer a terse response. 1.01. What is the ratio of the Completion rate(% of total enrollments) in Lao PDR in 2009 to that in 2010?
Provide a succinct answer. 0.95. What is the ratio of the Completion rate(% of total enrollments) in Poland in 2009 to that in 2010?
Your answer should be very brief. 0.99. What is the ratio of the Completion rate(% of total enrollments) of Ukraine in 2009 to that in 2010?
Your answer should be very brief. 0.97. What is the difference between the highest and the second highest Completion rate(% of total enrollments) of Dominican Republic?
Offer a very short reply. 1.08. What is the difference between the highest and the second highest Completion rate(% of total enrollments) of Lao PDR?
Make the answer very short. 4.55. What is the difference between the highest and the second highest Completion rate(% of total enrollments) in Poland?
Ensure brevity in your answer.  1.45. What is the difference between the highest and the second highest Completion rate(% of total enrollments) in Ukraine?
Give a very brief answer. 3.55. What is the difference between the highest and the lowest Completion rate(% of total enrollments) in Dominican Republic?
Your response must be concise. 14.8. What is the difference between the highest and the lowest Completion rate(% of total enrollments) in Lao PDR?
Your response must be concise. 15.87. What is the difference between the highest and the lowest Completion rate(% of total enrollments) in Poland?
Your response must be concise. 2.17. What is the difference between the highest and the lowest Completion rate(% of total enrollments) of Ukraine?
Your answer should be very brief. 13.2. 